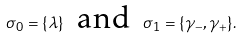<formula> <loc_0><loc_0><loc_500><loc_500>\sigma _ { 0 } = \{ \lambda \} \text {\, and \,} \sigma _ { 1 } = \{ \gamma _ { - } , \gamma _ { + } \} .</formula> 